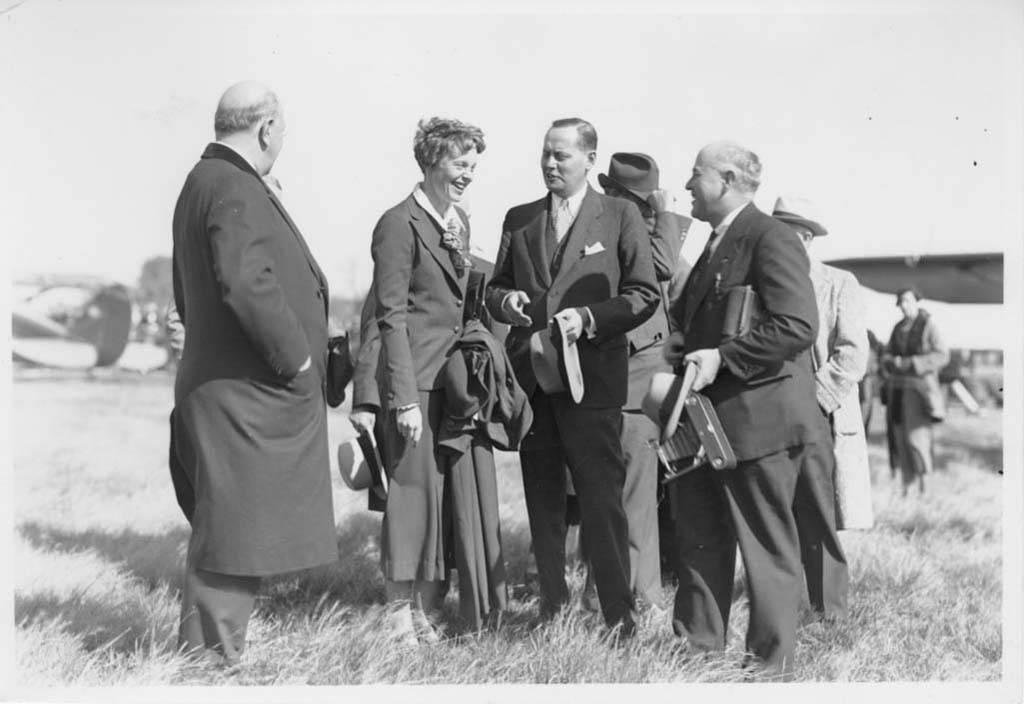What is the color scheme of the image? The image is black and white. What can be seen in the image? There is a group of people in the image. Where are the people standing? The people are standing on the grass. Can you describe the background of the image? The background of the image is blurred. How does the group of people increase their knowledge while standing on the grass in the image? There is no indication in the image that the group of people is increasing their knowledge or reading anything. 